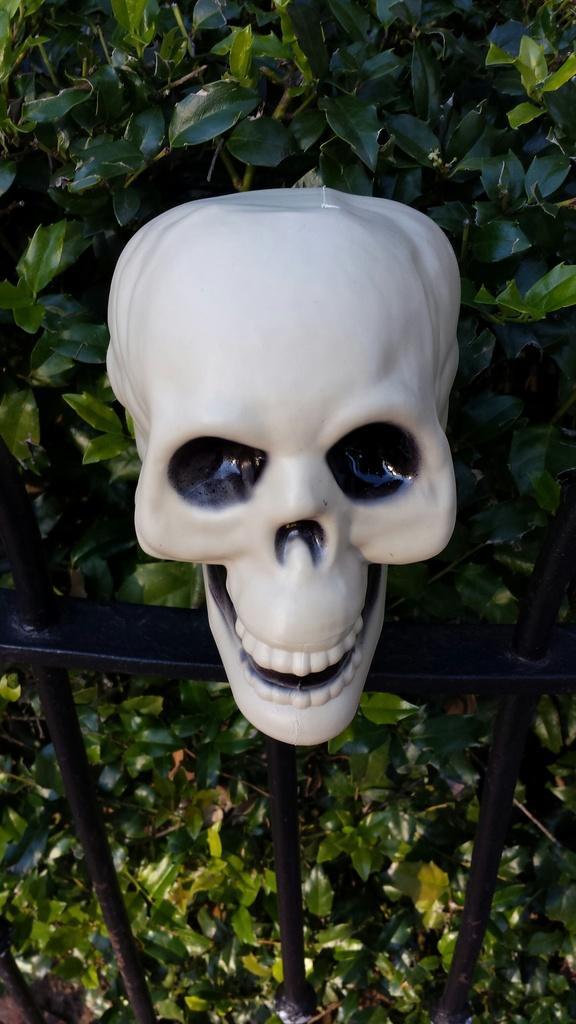Please provide a concise description of this image. In this picture there is a skull on the railing and there is a plant behind the railing. 